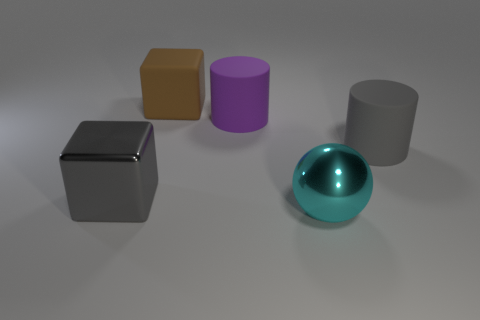Are the large block that is on the left side of the large brown cube and the large cube that is behind the large gray shiny thing made of the same material?
Give a very brief answer. No. What shape is the shiny thing that is to the left of the large cyan metal sphere?
Provide a succinct answer. Cube. There is a gray rubber thing that is the same shape as the big purple matte thing; what is its size?
Make the answer very short. Large. Is there any other thing that is the same shape as the large cyan object?
Offer a very short reply. No. There is a large gray thing that is behind the gray block; is there a big metallic cube behind it?
Your answer should be compact. No. There is another object that is the same shape as the gray rubber thing; what is its color?
Make the answer very short. Purple. How many large matte things are the same color as the big metal cube?
Keep it short and to the point. 1. What color is the large ball that is on the right side of the big metal object behind the metal object that is on the right side of the brown matte cube?
Ensure brevity in your answer.  Cyan. Are the gray cylinder and the big brown thing made of the same material?
Provide a succinct answer. Yes. Does the large brown rubber object have the same shape as the gray shiny thing?
Make the answer very short. Yes. 